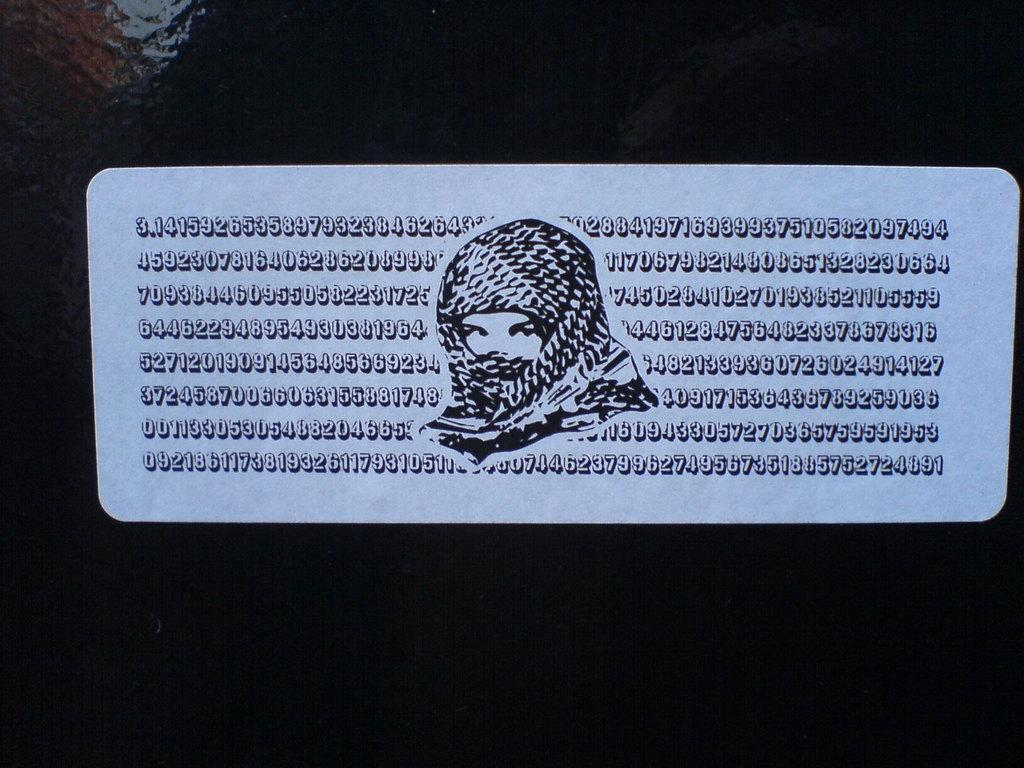What is the main subject of the image? The main subject of the image is a board with code. Is there anyone else in the image besides the board? Yes, there is a person in the middle of the image. What is the person wearing? The person is wearing a scarf. What type of disease is the person in the image suffering from? There is no indication in the image that the person is suffering from any disease. 